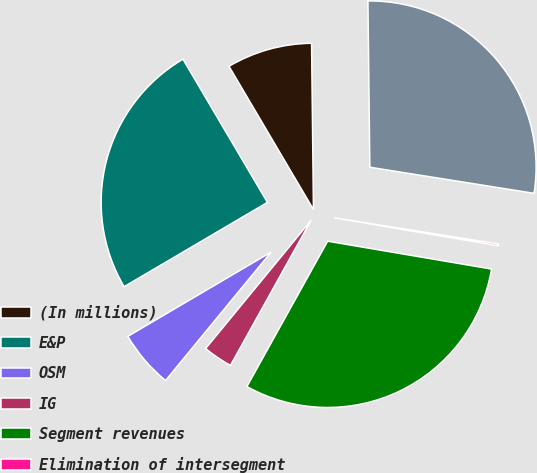Convert chart. <chart><loc_0><loc_0><loc_500><loc_500><pie_chart><fcel>(In millions)<fcel>E&P<fcel>OSM<fcel>IG<fcel>Segment revenues<fcel>Elimination of intersegment<fcel>Total revenues<nl><fcel>8.3%<fcel>24.98%<fcel>5.59%<fcel>2.88%<fcel>30.39%<fcel>0.17%<fcel>27.69%<nl></chart> 